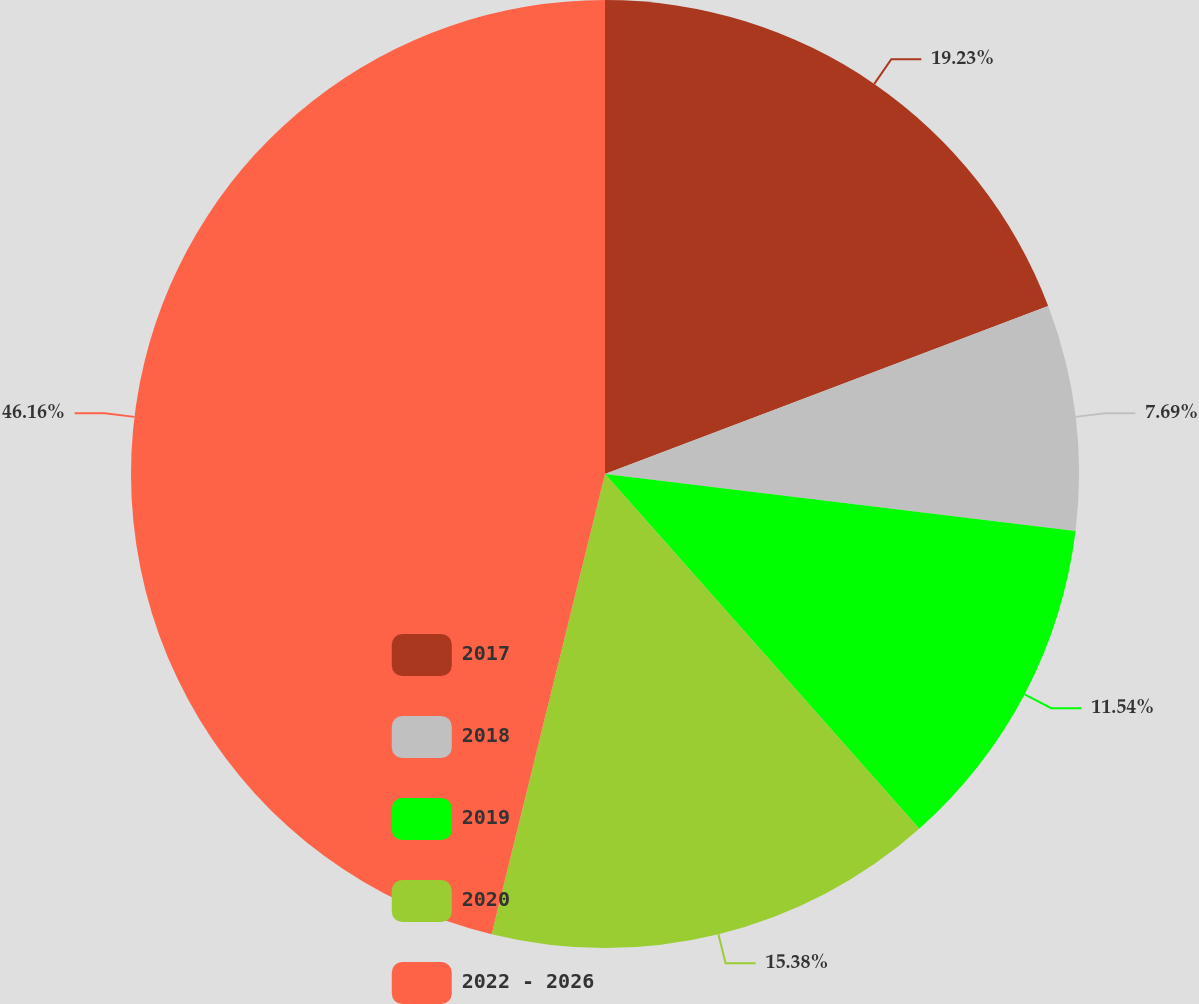<chart> <loc_0><loc_0><loc_500><loc_500><pie_chart><fcel>2017<fcel>2018<fcel>2019<fcel>2020<fcel>2022 - 2026<nl><fcel>19.23%<fcel>7.69%<fcel>11.54%<fcel>15.38%<fcel>46.15%<nl></chart> 